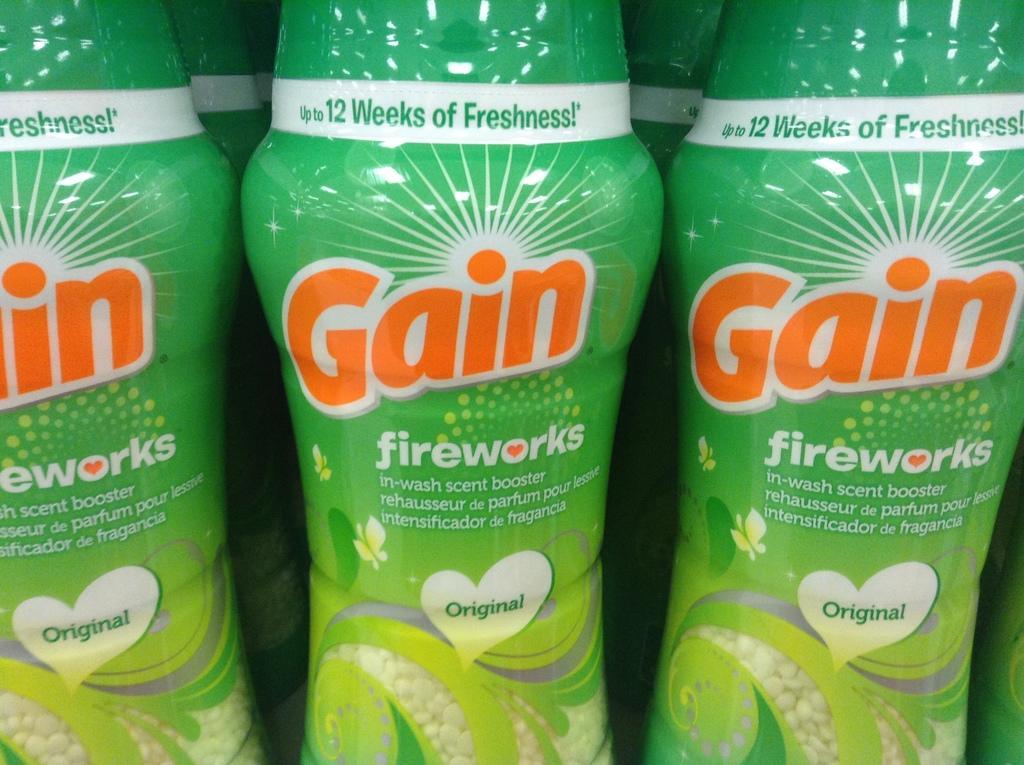How would you summarize this image in a sentence or two? Here these are the perfume bottles and there is a sticker on each bottle Gain fireworks scent booster 